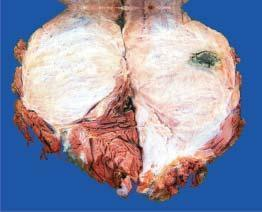s the lobulated tumour infiltrating the skeletal muscle somewhat circumscribed?
Answer the question using a single word or phrase. Yes 